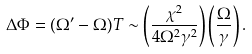<formula> <loc_0><loc_0><loc_500><loc_500>\Delta \Phi = ( \Omega ^ { \prime } - \Omega ) T \sim \left ( \frac { \chi ^ { 2 } } { 4 \Omega ^ { 2 } \gamma ^ { 2 } } \right ) \left ( \frac { \Omega } { \gamma } \right ) .</formula> 